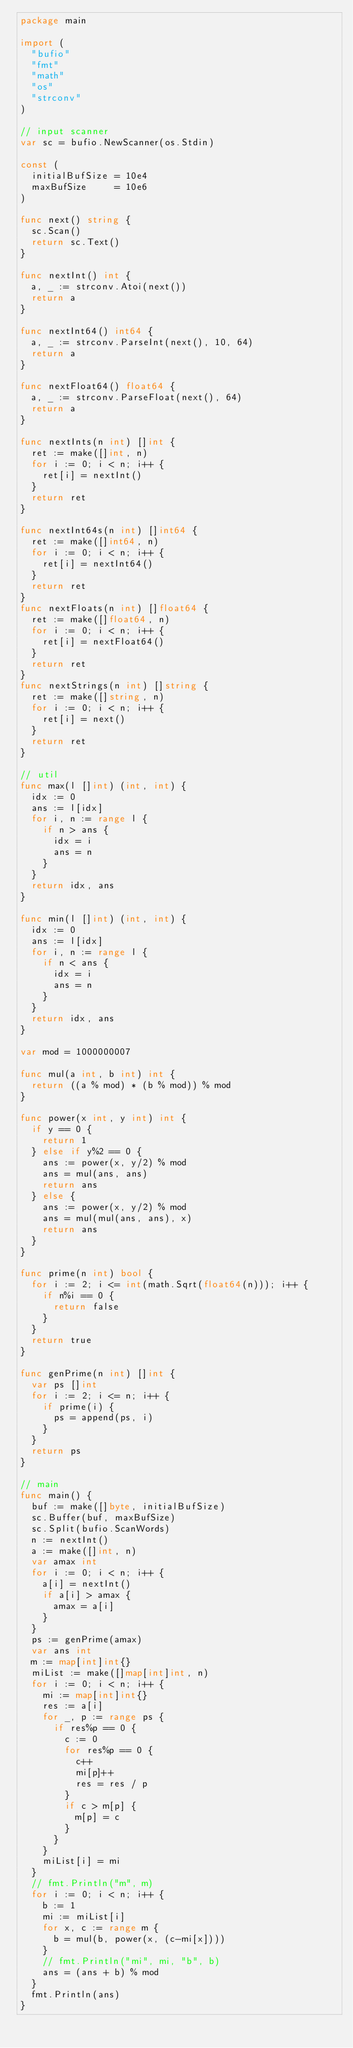<code> <loc_0><loc_0><loc_500><loc_500><_Go_>package main

import (
	"bufio"
	"fmt"
	"math"
	"os"
	"strconv"
)

// input scanner
var sc = bufio.NewScanner(os.Stdin)

const (
	initialBufSize = 10e4
	maxBufSize     = 10e6
)

func next() string {
	sc.Scan()
	return sc.Text()
}

func nextInt() int {
	a, _ := strconv.Atoi(next())
	return a
}

func nextInt64() int64 {
	a, _ := strconv.ParseInt(next(), 10, 64)
	return a
}

func nextFloat64() float64 {
	a, _ := strconv.ParseFloat(next(), 64)
	return a
}

func nextInts(n int) []int {
	ret := make([]int, n)
	for i := 0; i < n; i++ {
		ret[i] = nextInt()
	}
	return ret
}

func nextInt64s(n int) []int64 {
	ret := make([]int64, n)
	for i := 0; i < n; i++ {
		ret[i] = nextInt64()
	}
	return ret
}
func nextFloats(n int) []float64 {
	ret := make([]float64, n)
	for i := 0; i < n; i++ {
		ret[i] = nextFloat64()
	}
	return ret
}
func nextStrings(n int) []string {
	ret := make([]string, n)
	for i := 0; i < n; i++ {
		ret[i] = next()
	}
	return ret
}

// util
func max(l []int) (int, int) {
	idx := 0
	ans := l[idx]
	for i, n := range l {
		if n > ans {
			idx = i
			ans = n
		}
	}
	return idx, ans
}

func min(l []int) (int, int) {
	idx := 0
	ans := l[idx]
	for i, n := range l {
		if n < ans {
			idx = i
			ans = n
		}
	}
	return idx, ans
}

var mod = 1000000007

func mul(a int, b int) int {
	return ((a % mod) * (b % mod)) % mod
}

func power(x int, y int) int {
	if y == 0 {
		return 1
	} else if y%2 == 0 {
		ans := power(x, y/2) % mod
		ans = mul(ans, ans)
		return ans
	} else {
		ans := power(x, y/2) % mod
		ans = mul(mul(ans, ans), x)
		return ans
	}
}

func prime(n int) bool {
	for i := 2; i <= int(math.Sqrt(float64(n))); i++ {
		if n%i == 0 {
			return false
		}
	}
	return true
}

func genPrime(n int) []int {
	var ps []int
	for i := 2; i <= n; i++ {
		if prime(i) {
			ps = append(ps, i)
		}
	}
	return ps
}

// main
func main() {
	buf := make([]byte, initialBufSize)
	sc.Buffer(buf, maxBufSize)
	sc.Split(bufio.ScanWords)
	n := nextInt()
	a := make([]int, n)
	var amax int
	for i := 0; i < n; i++ {
		a[i] = nextInt()
		if a[i] > amax {
			amax = a[i]
		}
	}
	ps := genPrime(amax)
	var ans int
	m := map[int]int{}
	miList := make([]map[int]int, n)
	for i := 0; i < n; i++ {
		mi := map[int]int{}
		res := a[i]
		for _, p := range ps {
			if res%p == 0 {
				c := 0
				for res%p == 0 {
					c++
					mi[p]++
					res = res / p
				}
				if c > m[p] {
					m[p] = c
				}
			}
		}
		miList[i] = mi
	}
	// fmt.Println("m", m)
	for i := 0; i < n; i++ {
		b := 1
		mi := miList[i]
		for x, c := range m {
			b = mul(b, power(x, (c-mi[x])))
		}
		// fmt.Println("mi", mi, "b", b)
		ans = (ans + b) % mod
	}
	fmt.Println(ans)
}
</code> 